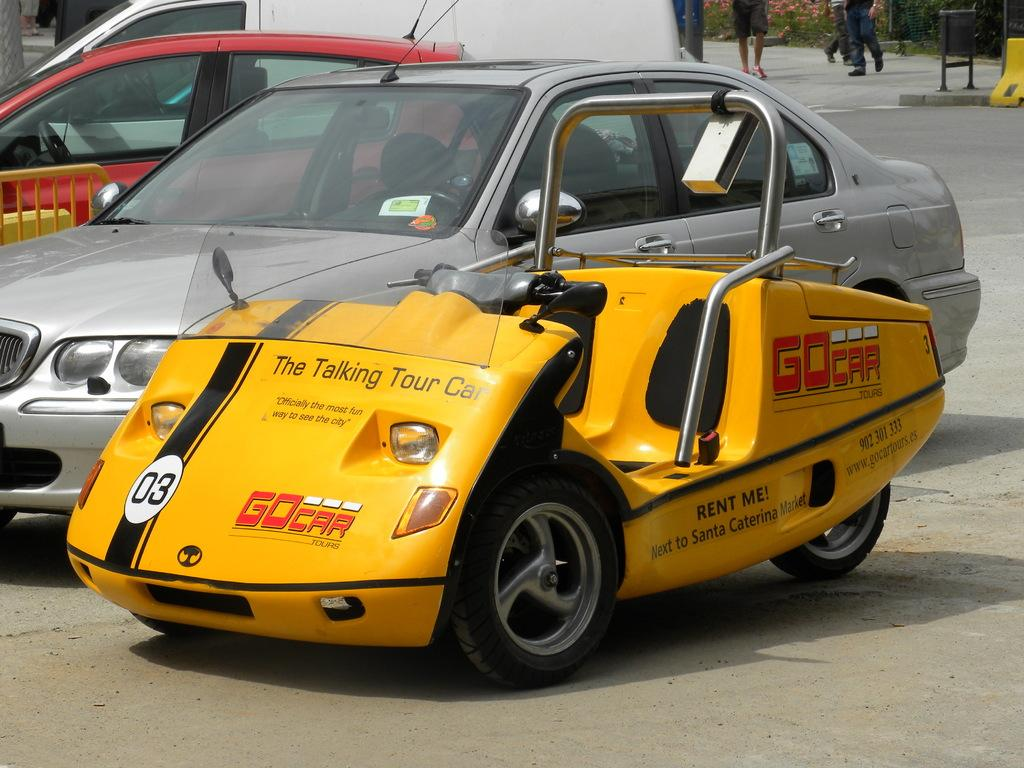Provide a one-sentence caption for the provided image. The talking tour car can be rented and is in the parking lot. 